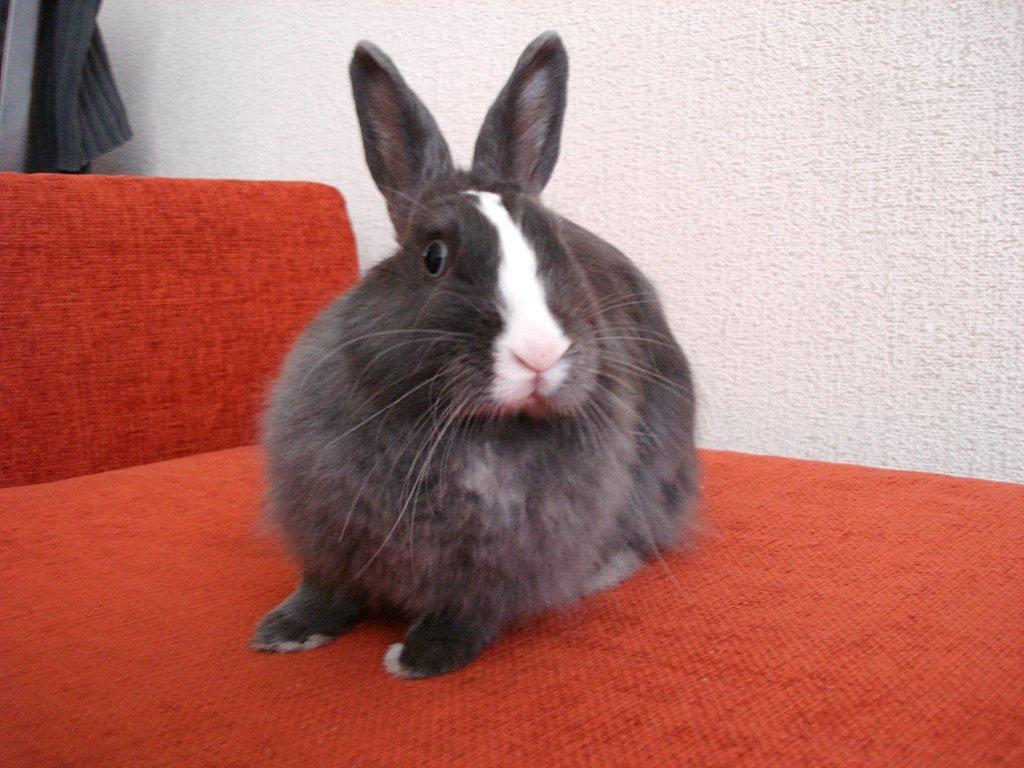Could you give a brief overview of what you see in this image? Above the red couch there is a rabbit. In the background we can see white wall and woolen cloth. 